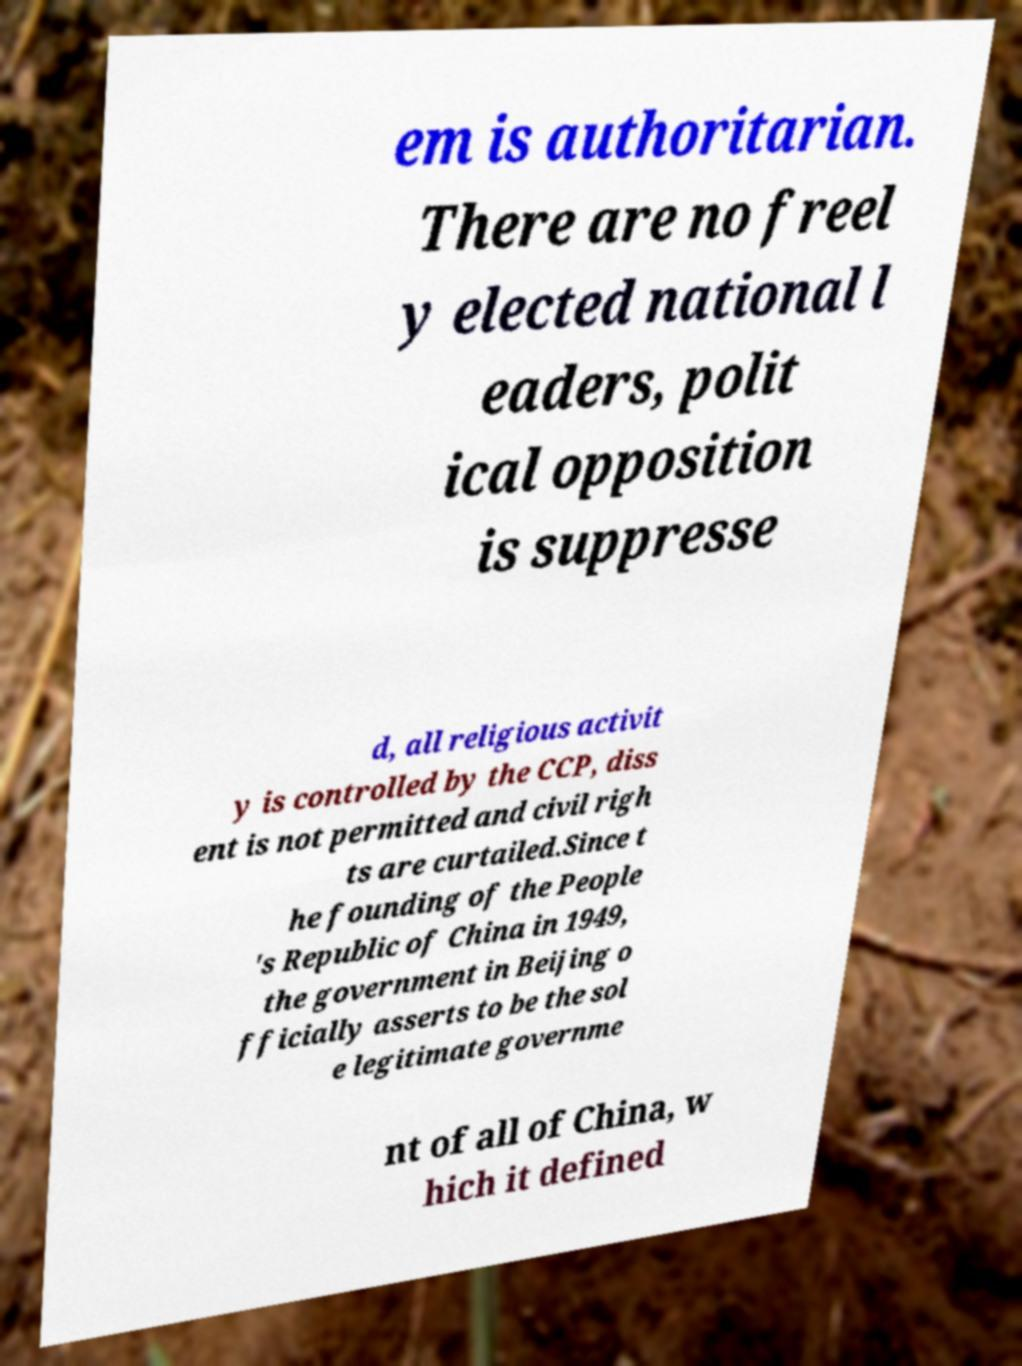There's text embedded in this image that I need extracted. Can you transcribe it verbatim? em is authoritarian. There are no freel y elected national l eaders, polit ical opposition is suppresse d, all religious activit y is controlled by the CCP, diss ent is not permitted and civil righ ts are curtailed.Since t he founding of the People 's Republic of China in 1949, the government in Beijing o fficially asserts to be the sol e legitimate governme nt of all of China, w hich it defined 